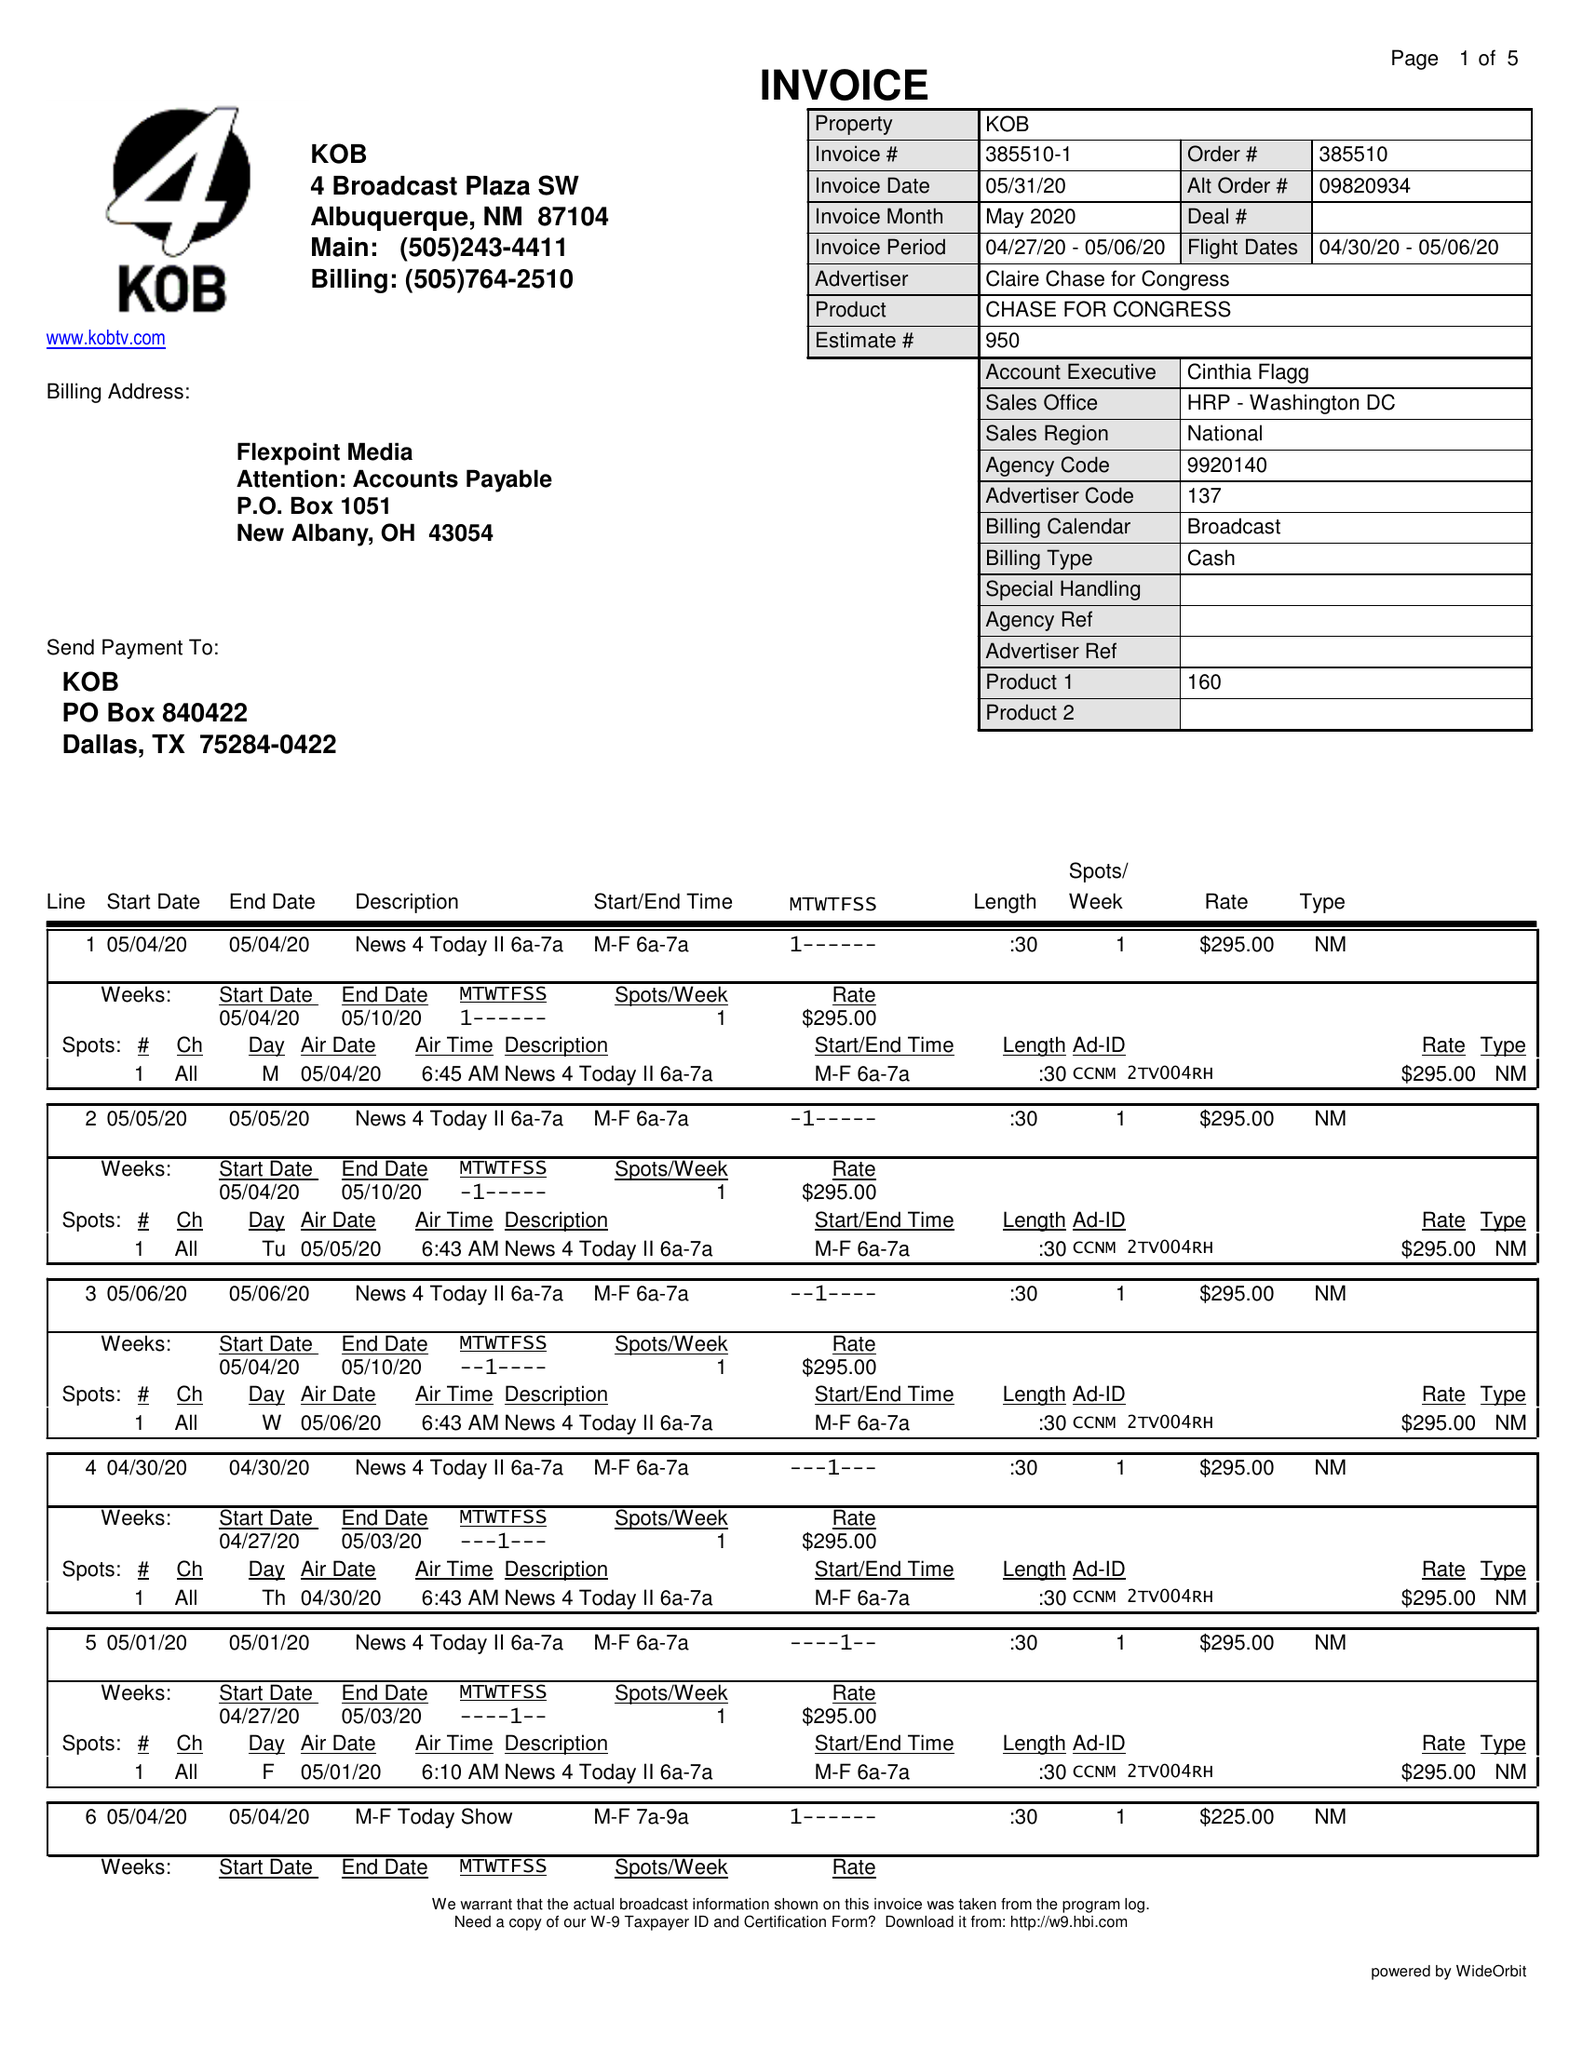What is the value for the advertiser?
Answer the question using a single word or phrase. CLAIRE CHASE FOR CONGRESS 